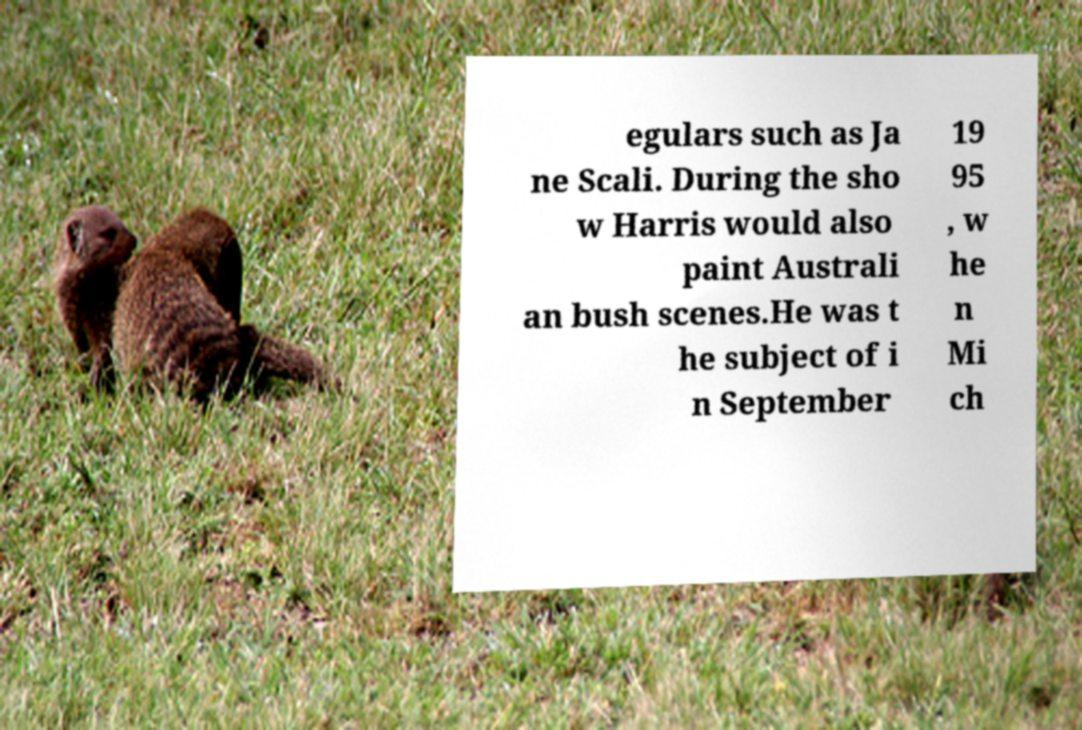There's text embedded in this image that I need extracted. Can you transcribe it verbatim? egulars such as Ja ne Scali. During the sho w Harris would also paint Australi an bush scenes.He was t he subject of i n September 19 95 , w he n Mi ch 